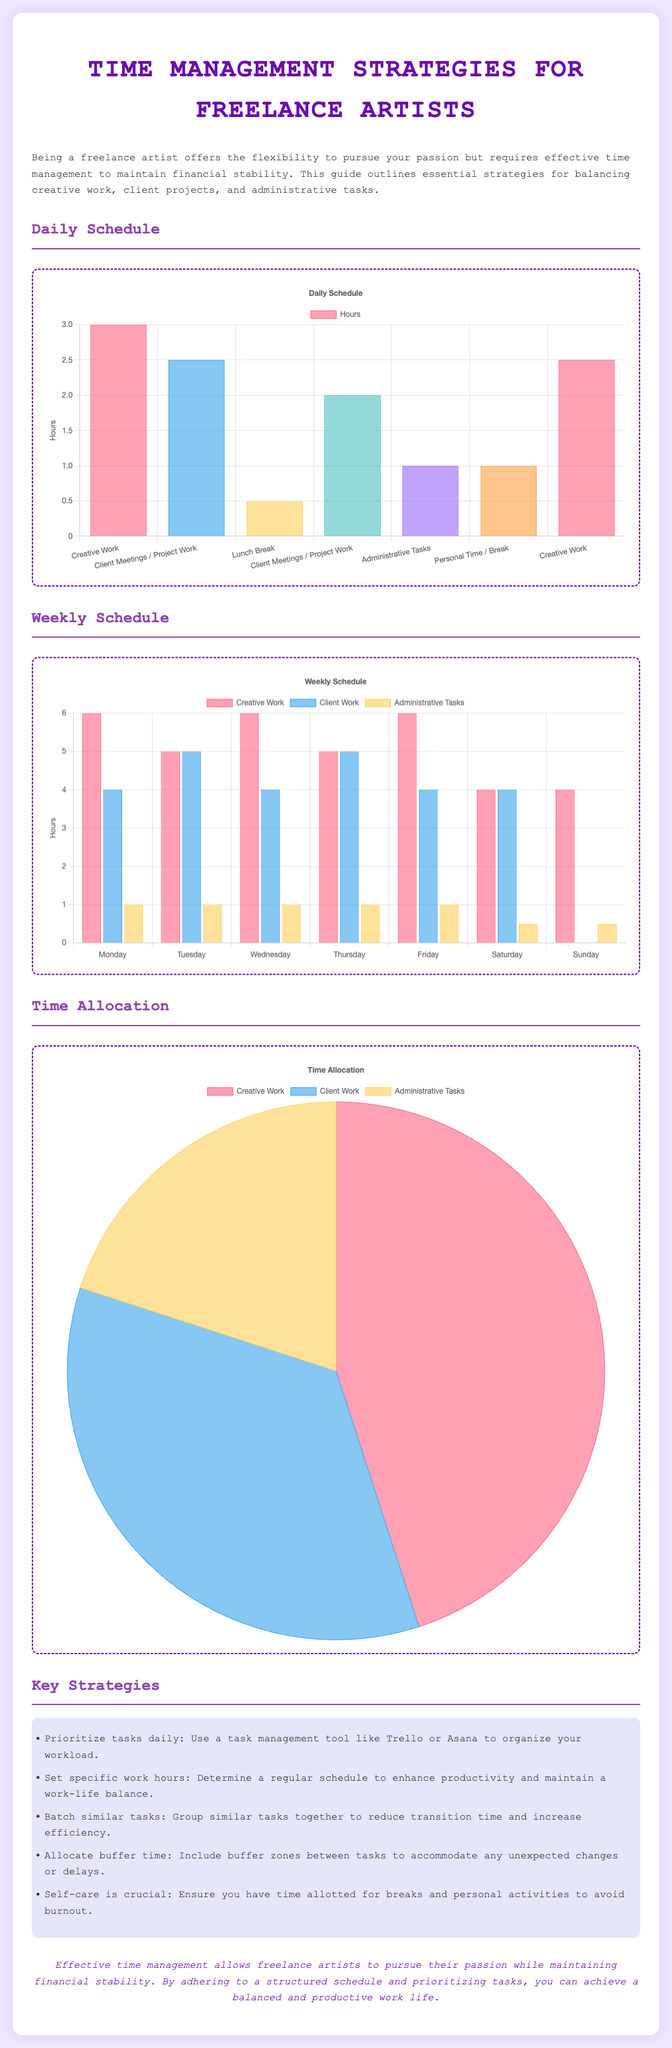what is the total hours allocated for creative work in the daily schedule? The total hours for creative work in the daily schedule are 3 + 2.5 = 5.5 hours.
Answer: 5.5 hours how many hours are dedicated to client work on Tuesday? The number of hours dedicated to client work on Tuesday in the weekly schedule is shown as 5 hours.
Answer: 5 hours what percentage of time is allocated to administrative tasks in the pie chart? The pie chart shows that administrative tasks account for 20% of the total time allocation.
Answer: 20% which day has the least hours for creative work in the weekly schedule? In the weekly schedule, Saturday has the least hours allocated for creative work with 4 hours.
Answer: Saturday what are the top two strategies listed for time management? The top two strategies listed for time management are prioritize tasks daily and set specific work hours.
Answer: prioritize tasks daily, set specific work hours how many hours are allocated for lunch breaks in the daily schedule? The daily schedule allocates 0.5 hours for lunch breaks.
Answer: 0.5 hours what is the main type of work scheduled for Sunday? The primary type of work scheduled for Sunday is administrative tasks, with only 0.5 hours allocated.
Answer: administrative tasks in total, how many hours are allocated for administrative tasks during the week? The total hours allocated for administrative tasks during the week is 1 + 1 + 1 + 1 + 1 + 0.5 + 0.5 = 5 hours.
Answer: 5 hours 